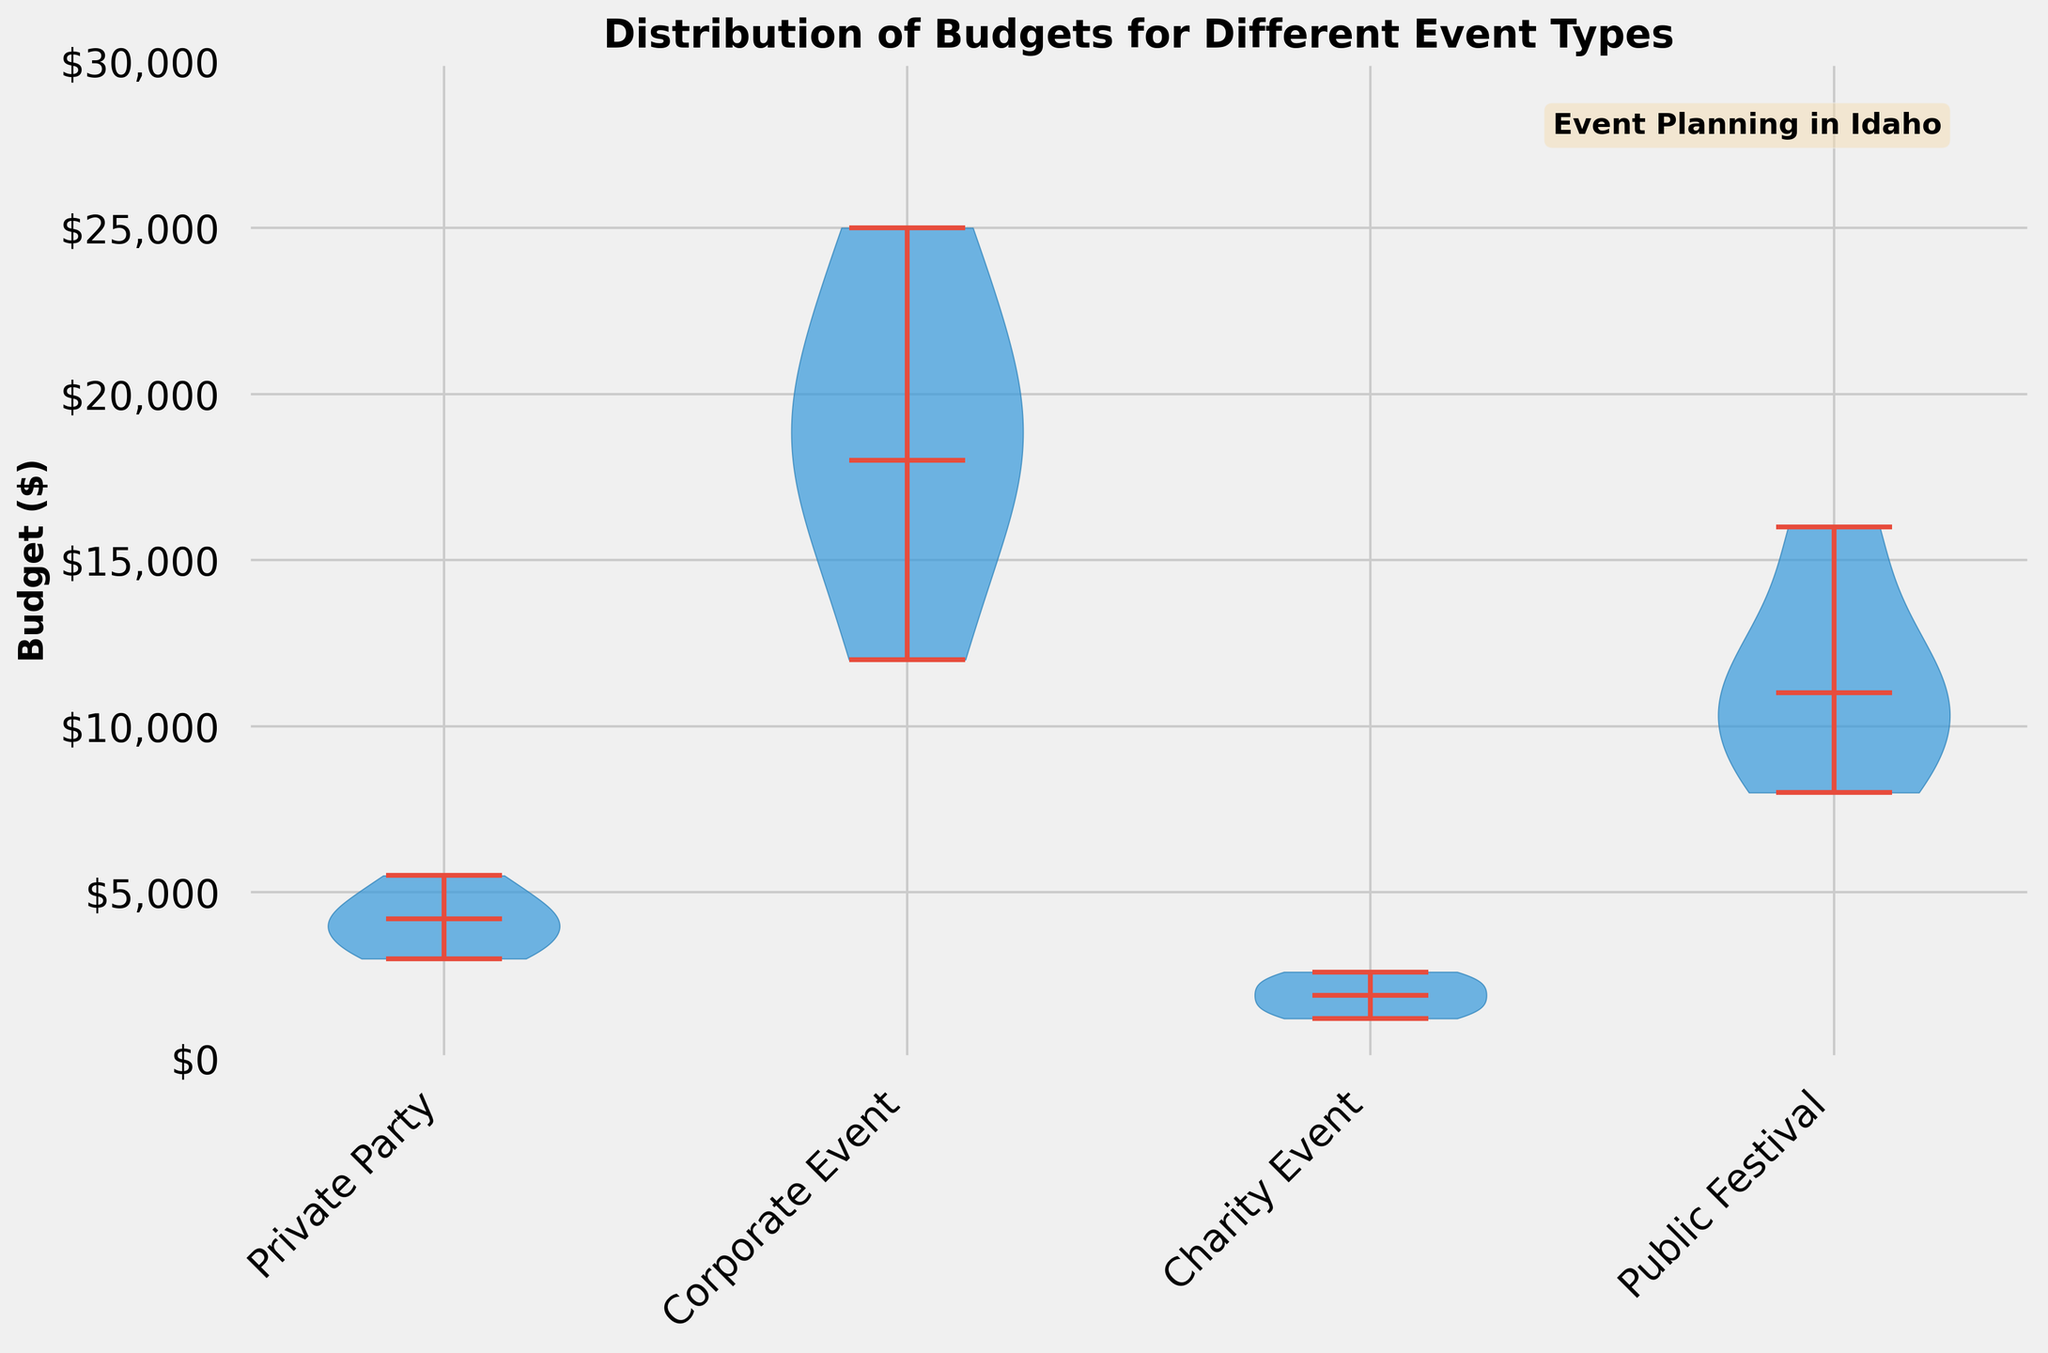What is the title of the figure? The title of the figure can be found at the top of the plot. It says 'Distribution of Budgets for Different Event Types'.
Answer: Distribution of Budgets for Different Event Types Which event type has the highest median budget? Looking at the violin plots, the horizontal line inside each violin represents the median. The Corporate Event type has the highest median budget, as its median line is positioned higher compared to the others.
Answer: Corporate Event What is the median budget for Charity Events? To find this, look at the violin plot for Charity Events. The horizontal line inside this violin represents the median budget.
Answer: $1900 How do the budgets for Public Festivals compare to Corporate Events in terms of median values? The violin plot for Corporate Events has a higher median line than Public Festivals, indicating that Corporate Events have a higher median budget.
Answer: Corporate Events have a higher median budget What is the range of budgets for Private Parties? The range can be determined by looking at the minimum and maximum points on the y-axis within the Private Party violin plot. The minimum is $3000, and the maximum is $5500.
Answer: $2500 What is the range of budgets for Corporate Events? To find the range for Corporate Events, look at the maximum and minimum extents of the violin plot. The minimum budget is $12000, and the maximum is $25000.
Answer: $13000 Which event type shows the highest variability in budget? The event type with the widest spread in its violin plot indicates the highest variability. Corporate Events have the widest spread from $12000 to $25000, indicating the highest variability.
Answer: Corporate Events How does the most expensive Public Festival budget compare to the least expensive Corporate Event budget? Comparing the maximum budget for Public Festivals to the minimum budget for Corporate Events will give the answer. The maximum Public Festival budget is $16000, and the minimum Corporate Event budget is $12000.
Answer: $4000 higher In which event type is the lowest budget observed? The lowest budget can be observed at the bottommost point of the violin plots. Charity Events have the lowest budget observed at $1200.
Answer: Charity Events How does the median budget of Corporate Events compare to the median budget of Private Parties? Compare the position of the median lines in the violin plots for Corporate Events and Private Parties. The Corporate Events median line is higher than the Private Parties median line.
Answer: Corporate Events have a higher median budget 